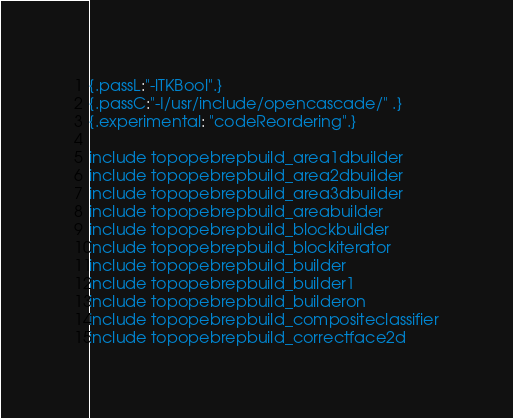Convert code to text. <code><loc_0><loc_0><loc_500><loc_500><_Nim_>{.passL:"-lTKBool".}
{.passC:"-I/usr/include/opencascade/" .}
{.experimental: "codeReordering".}

include topopebrepbuild_area1dbuilder
include topopebrepbuild_area2dbuilder
include topopebrepbuild_area3dbuilder
include topopebrepbuild_areabuilder
include topopebrepbuild_blockbuilder
include topopebrepbuild_blockiterator
include topopebrepbuild_builder
include topopebrepbuild_builder1
include topopebrepbuild_builderon
include topopebrepbuild_compositeclassifier
include topopebrepbuild_correctface2d</code> 